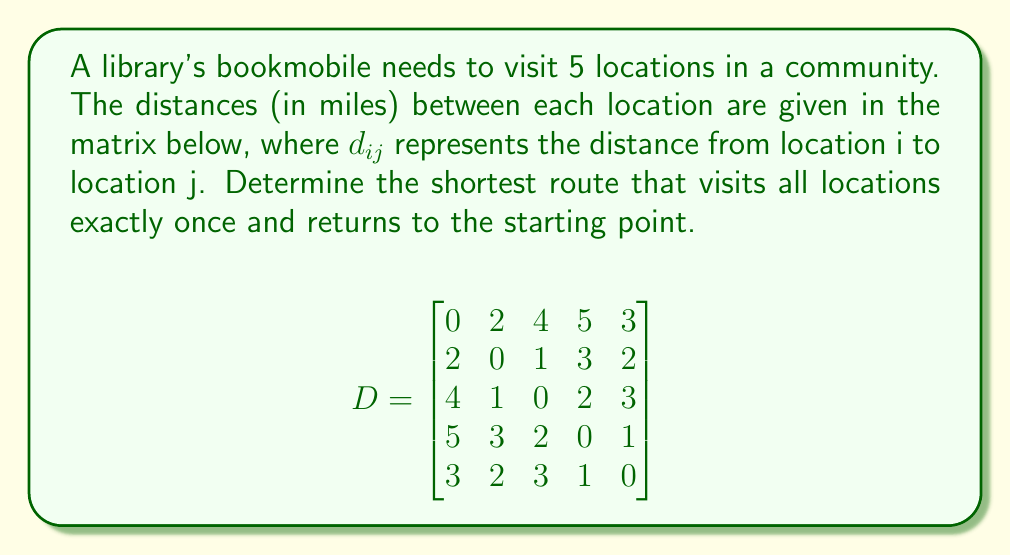Could you help me with this problem? To solve this problem, we need to use the Traveling Salesman Problem (TSP) approach. Since there are only 5 locations, we can use the brute force method to find the optimal solution.

Step 1: List all possible routes.
There are (5-1)! = 24 possible routes, as we fix the starting point.

Step 2: Calculate the total distance for each route.
For example, let's calculate the distance for route 1-2-3-4-5-1:
$d_{12} + d_{23} + d_{34} + d_{45} + d_{51} = 2 + 1 + 2 + 1 + 3 = 9$ miles

Step 3: Repeat step 2 for all 24 routes and find the minimum.

After calculating all routes, we find that the shortest route is 1-5-4-3-2-1 with a total distance of:

$d_{15} + d_{54} + d_{43} + d_{32} + d_{21} = 3 + 1 + 2 + 1 + 2 = 9$ miles

This route represents the most efficient path for the bookmobile to serve all locations and return to its starting point.
Answer: 1-5-4-3-2-1, 9 miles 